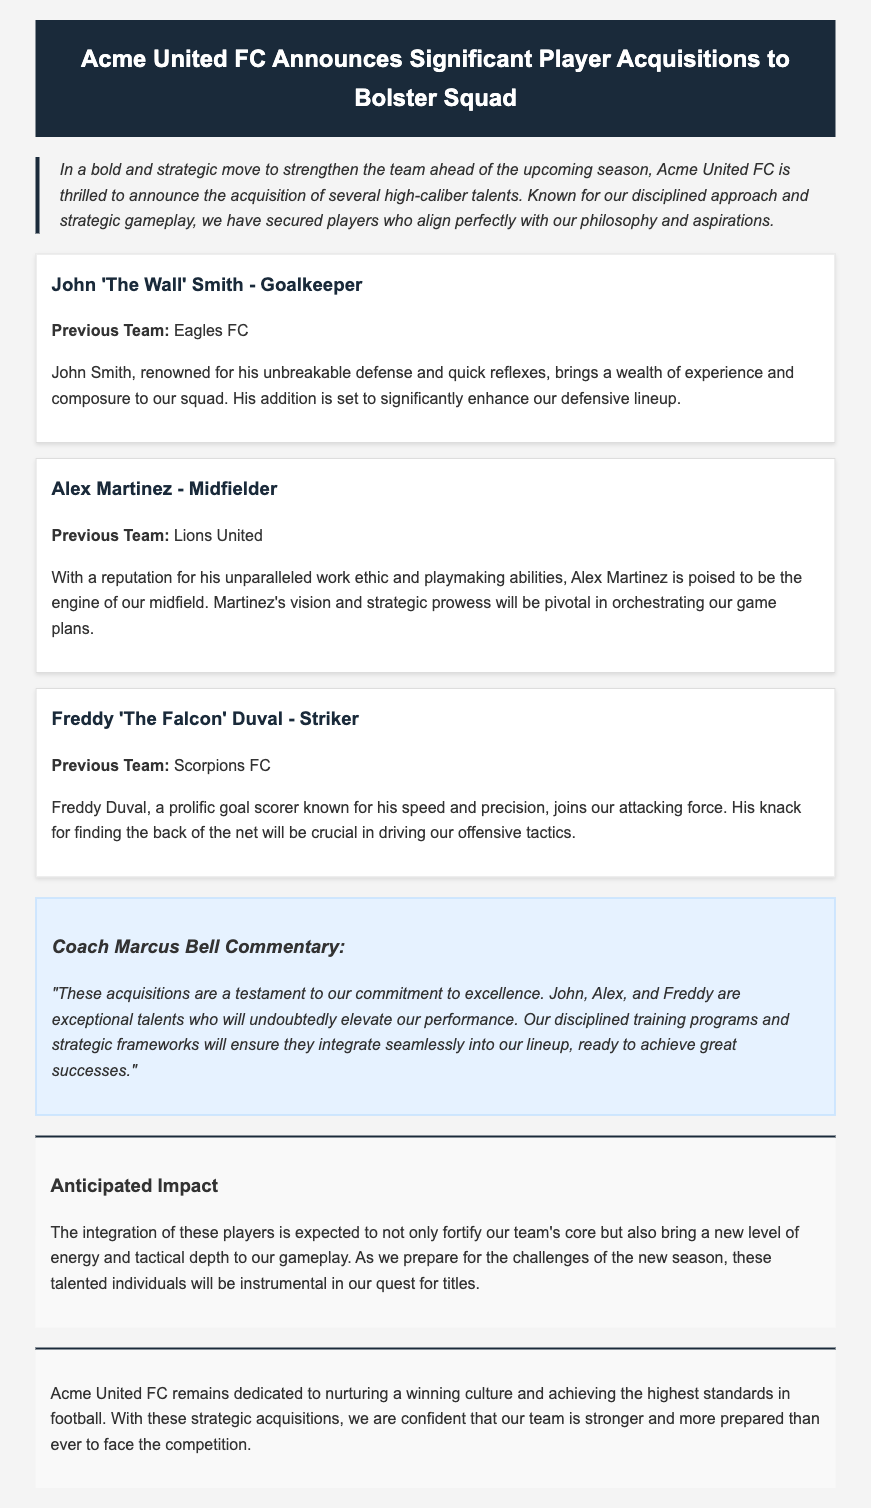What is the name of the team making the acquisitions? The document states that Acme United FC is the team making the acquisitions.
Answer: Acme United FC Who is the goalkeeper acquired? The name of the goalkeeper mentioned in the document is John 'The Wall' Smith.
Answer: John 'The Wall' Smith Which previous team did Freddy Duval come from? The document specifies that Freddy 'The Falcon' Duval previously played for Scorpions FC.
Answer: Scorpions FC What position does Alex Martinez play? The document identifies Alex Martinez as a midfielder.
Answer: Midfielder What is Coach Marcus Bell's main message regarding the acquisitions? Coach Marcus Bell expresses that the acquisitions are a testament to commitment to excellence and will elevate performance.
Answer: Commitment to excellence How many players were acquired according to the document? The document lists three players who were acquired by the team.
Answer: Three What is the anticipated impact of these acquisitions? The document mentions that the acquisitions will not only fortify the team's core but also bring a new level of energy and tactical depth.
Answer: Fortify the team's core What is the overall message of Acme United FC's press release? The press release conveys that Acme United FC is dedicated to nurturing a winning culture and achieving the highest standards in football.
Answer: Winning culture What type of press release is this document? This document is categorized as a player acquisition announcement.
Answer: Player acquisition announcement 